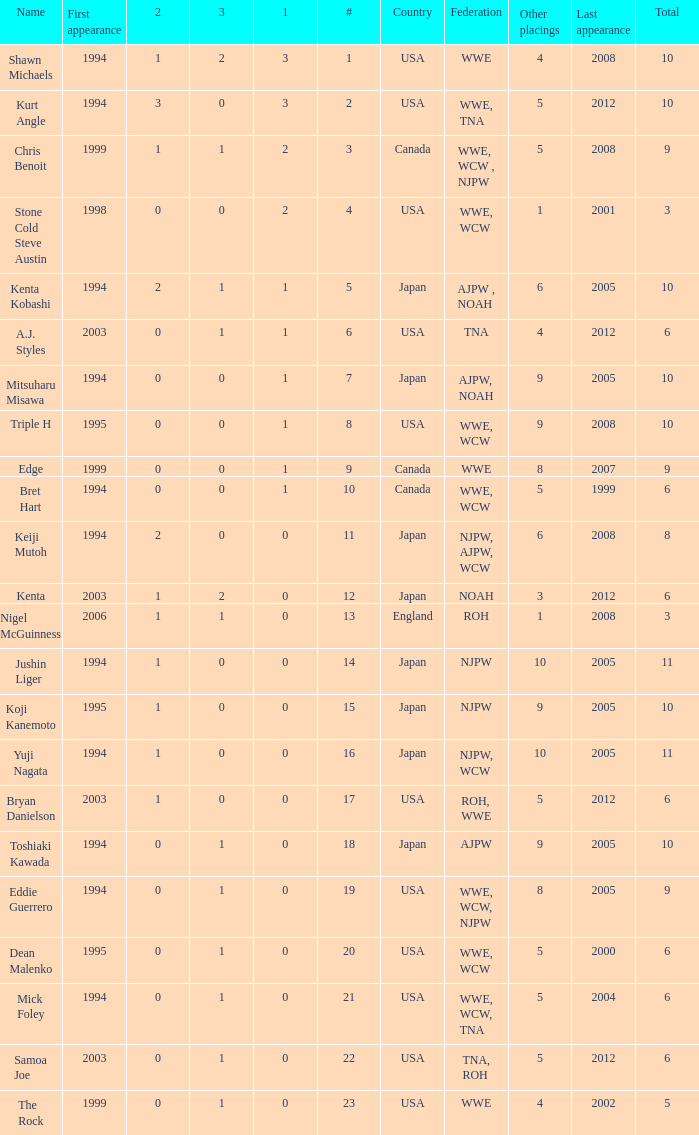What countries does the Rock come from? 1.0. 